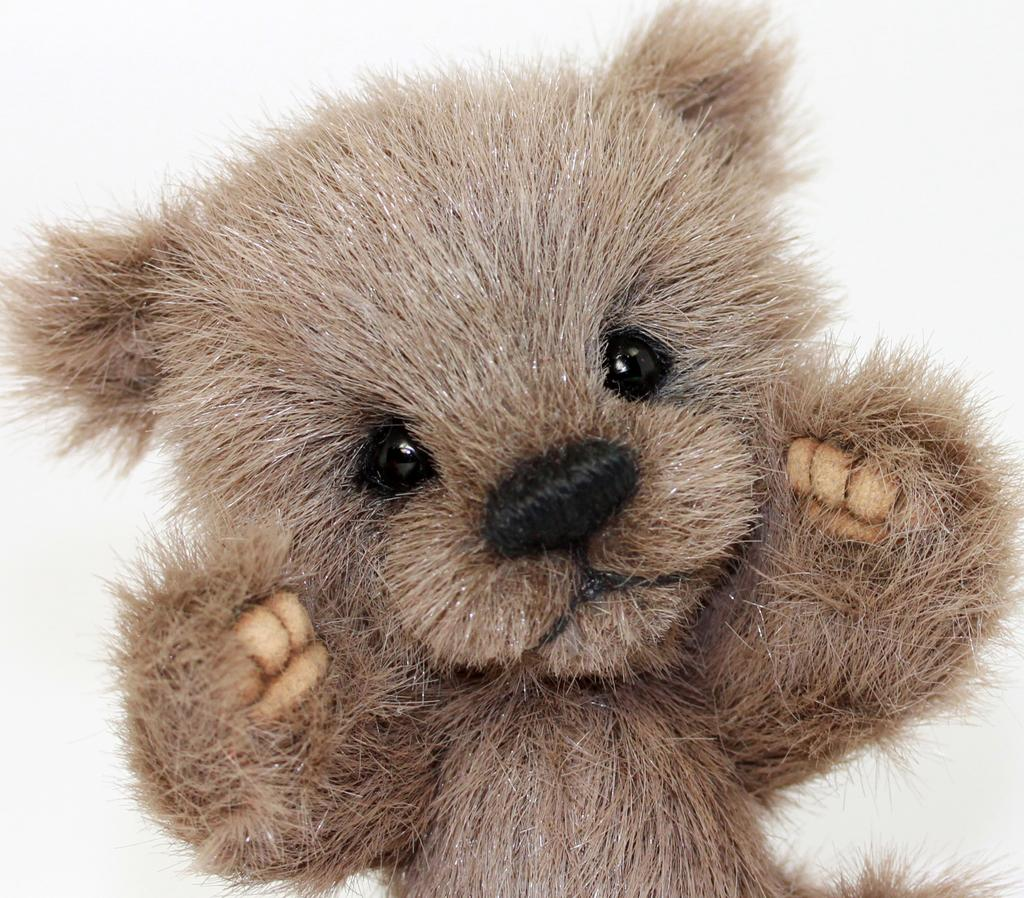What type of toy is present in the image? There is a brown color small teddy bear toy in the image. What is the color of the teddy bear toy? The teddy bear toy is brown in color. What type of rifle is the teddy bear holding in the image? The teddy bear is not holding a rifle in the image; it is a toy and does not have any weapons. 